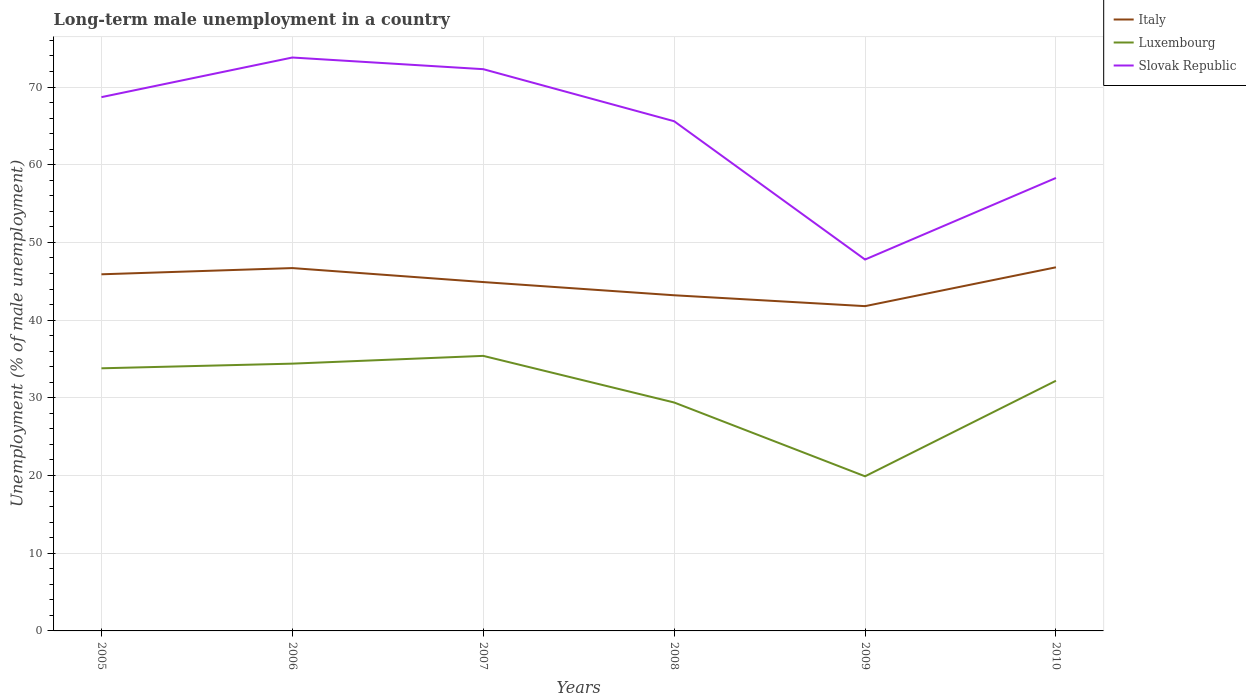Is the number of lines equal to the number of legend labels?
Offer a terse response. Yes. Across all years, what is the maximum percentage of long-term unemployed male population in Slovak Republic?
Give a very brief answer. 47.8. In which year was the percentage of long-term unemployed male population in Luxembourg maximum?
Offer a very short reply. 2009. What is the total percentage of long-term unemployed male population in Luxembourg in the graph?
Give a very brief answer. -1.6. What is the difference between the highest and the second highest percentage of long-term unemployed male population in Luxembourg?
Your response must be concise. 15.5. How many years are there in the graph?
Your answer should be compact. 6. What is the difference between two consecutive major ticks on the Y-axis?
Your response must be concise. 10. Does the graph contain grids?
Provide a succinct answer. Yes. Where does the legend appear in the graph?
Offer a very short reply. Top right. How are the legend labels stacked?
Your response must be concise. Vertical. What is the title of the graph?
Offer a terse response. Long-term male unemployment in a country. Does "Sub-Saharan Africa (all income levels)" appear as one of the legend labels in the graph?
Offer a very short reply. No. What is the label or title of the X-axis?
Give a very brief answer. Years. What is the label or title of the Y-axis?
Make the answer very short. Unemployment (% of male unemployment). What is the Unemployment (% of male unemployment) in Italy in 2005?
Ensure brevity in your answer.  45.9. What is the Unemployment (% of male unemployment) in Luxembourg in 2005?
Your answer should be compact. 33.8. What is the Unemployment (% of male unemployment) in Slovak Republic in 2005?
Offer a very short reply. 68.7. What is the Unemployment (% of male unemployment) of Italy in 2006?
Ensure brevity in your answer.  46.7. What is the Unemployment (% of male unemployment) in Luxembourg in 2006?
Ensure brevity in your answer.  34.4. What is the Unemployment (% of male unemployment) in Slovak Republic in 2006?
Give a very brief answer. 73.8. What is the Unemployment (% of male unemployment) of Italy in 2007?
Ensure brevity in your answer.  44.9. What is the Unemployment (% of male unemployment) of Luxembourg in 2007?
Offer a very short reply. 35.4. What is the Unemployment (% of male unemployment) in Slovak Republic in 2007?
Offer a very short reply. 72.3. What is the Unemployment (% of male unemployment) of Italy in 2008?
Offer a terse response. 43.2. What is the Unemployment (% of male unemployment) of Luxembourg in 2008?
Your response must be concise. 29.4. What is the Unemployment (% of male unemployment) in Slovak Republic in 2008?
Your answer should be very brief. 65.6. What is the Unemployment (% of male unemployment) in Italy in 2009?
Ensure brevity in your answer.  41.8. What is the Unemployment (% of male unemployment) of Luxembourg in 2009?
Offer a very short reply. 19.9. What is the Unemployment (% of male unemployment) of Slovak Republic in 2009?
Offer a very short reply. 47.8. What is the Unemployment (% of male unemployment) of Italy in 2010?
Your response must be concise. 46.8. What is the Unemployment (% of male unemployment) in Luxembourg in 2010?
Ensure brevity in your answer.  32.2. What is the Unemployment (% of male unemployment) in Slovak Republic in 2010?
Your answer should be very brief. 58.3. Across all years, what is the maximum Unemployment (% of male unemployment) of Italy?
Your answer should be compact. 46.8. Across all years, what is the maximum Unemployment (% of male unemployment) in Luxembourg?
Your answer should be compact. 35.4. Across all years, what is the maximum Unemployment (% of male unemployment) in Slovak Republic?
Make the answer very short. 73.8. Across all years, what is the minimum Unemployment (% of male unemployment) of Italy?
Ensure brevity in your answer.  41.8. Across all years, what is the minimum Unemployment (% of male unemployment) of Luxembourg?
Provide a succinct answer. 19.9. Across all years, what is the minimum Unemployment (% of male unemployment) of Slovak Republic?
Your answer should be compact. 47.8. What is the total Unemployment (% of male unemployment) in Italy in the graph?
Ensure brevity in your answer.  269.3. What is the total Unemployment (% of male unemployment) of Luxembourg in the graph?
Give a very brief answer. 185.1. What is the total Unemployment (% of male unemployment) of Slovak Republic in the graph?
Provide a succinct answer. 386.5. What is the difference between the Unemployment (% of male unemployment) in Italy in 2005 and that in 2006?
Offer a very short reply. -0.8. What is the difference between the Unemployment (% of male unemployment) of Slovak Republic in 2005 and that in 2006?
Give a very brief answer. -5.1. What is the difference between the Unemployment (% of male unemployment) of Slovak Republic in 2005 and that in 2007?
Offer a very short reply. -3.6. What is the difference between the Unemployment (% of male unemployment) of Italy in 2005 and that in 2008?
Your response must be concise. 2.7. What is the difference between the Unemployment (% of male unemployment) of Slovak Republic in 2005 and that in 2008?
Your answer should be very brief. 3.1. What is the difference between the Unemployment (% of male unemployment) in Italy in 2005 and that in 2009?
Provide a short and direct response. 4.1. What is the difference between the Unemployment (% of male unemployment) in Slovak Republic in 2005 and that in 2009?
Provide a succinct answer. 20.9. What is the difference between the Unemployment (% of male unemployment) in Italy in 2005 and that in 2010?
Offer a very short reply. -0.9. What is the difference between the Unemployment (% of male unemployment) in Luxembourg in 2005 and that in 2010?
Make the answer very short. 1.6. What is the difference between the Unemployment (% of male unemployment) of Slovak Republic in 2005 and that in 2010?
Ensure brevity in your answer.  10.4. What is the difference between the Unemployment (% of male unemployment) of Slovak Republic in 2006 and that in 2008?
Your answer should be very brief. 8.2. What is the difference between the Unemployment (% of male unemployment) in Italy in 2006 and that in 2009?
Provide a succinct answer. 4.9. What is the difference between the Unemployment (% of male unemployment) of Slovak Republic in 2006 and that in 2009?
Ensure brevity in your answer.  26. What is the difference between the Unemployment (% of male unemployment) in Slovak Republic in 2006 and that in 2010?
Your answer should be compact. 15.5. What is the difference between the Unemployment (% of male unemployment) in Italy in 2007 and that in 2008?
Offer a terse response. 1.7. What is the difference between the Unemployment (% of male unemployment) of Luxembourg in 2007 and that in 2008?
Your answer should be compact. 6. What is the difference between the Unemployment (% of male unemployment) of Slovak Republic in 2007 and that in 2008?
Give a very brief answer. 6.7. What is the difference between the Unemployment (% of male unemployment) of Italy in 2008 and that in 2009?
Make the answer very short. 1.4. What is the difference between the Unemployment (% of male unemployment) of Luxembourg in 2008 and that in 2009?
Your answer should be very brief. 9.5. What is the difference between the Unemployment (% of male unemployment) of Slovak Republic in 2008 and that in 2009?
Offer a very short reply. 17.8. What is the difference between the Unemployment (% of male unemployment) of Slovak Republic in 2008 and that in 2010?
Keep it short and to the point. 7.3. What is the difference between the Unemployment (% of male unemployment) of Luxembourg in 2009 and that in 2010?
Ensure brevity in your answer.  -12.3. What is the difference between the Unemployment (% of male unemployment) in Slovak Republic in 2009 and that in 2010?
Offer a very short reply. -10.5. What is the difference between the Unemployment (% of male unemployment) of Italy in 2005 and the Unemployment (% of male unemployment) of Luxembourg in 2006?
Offer a very short reply. 11.5. What is the difference between the Unemployment (% of male unemployment) in Italy in 2005 and the Unemployment (% of male unemployment) in Slovak Republic in 2006?
Offer a very short reply. -27.9. What is the difference between the Unemployment (% of male unemployment) in Luxembourg in 2005 and the Unemployment (% of male unemployment) in Slovak Republic in 2006?
Offer a very short reply. -40. What is the difference between the Unemployment (% of male unemployment) of Italy in 2005 and the Unemployment (% of male unemployment) of Luxembourg in 2007?
Offer a terse response. 10.5. What is the difference between the Unemployment (% of male unemployment) in Italy in 2005 and the Unemployment (% of male unemployment) in Slovak Republic in 2007?
Your answer should be very brief. -26.4. What is the difference between the Unemployment (% of male unemployment) of Luxembourg in 2005 and the Unemployment (% of male unemployment) of Slovak Republic in 2007?
Keep it short and to the point. -38.5. What is the difference between the Unemployment (% of male unemployment) in Italy in 2005 and the Unemployment (% of male unemployment) in Luxembourg in 2008?
Make the answer very short. 16.5. What is the difference between the Unemployment (% of male unemployment) in Italy in 2005 and the Unemployment (% of male unemployment) in Slovak Republic in 2008?
Offer a terse response. -19.7. What is the difference between the Unemployment (% of male unemployment) in Luxembourg in 2005 and the Unemployment (% of male unemployment) in Slovak Republic in 2008?
Your answer should be compact. -31.8. What is the difference between the Unemployment (% of male unemployment) in Italy in 2005 and the Unemployment (% of male unemployment) in Slovak Republic in 2009?
Provide a succinct answer. -1.9. What is the difference between the Unemployment (% of male unemployment) in Luxembourg in 2005 and the Unemployment (% of male unemployment) in Slovak Republic in 2009?
Make the answer very short. -14. What is the difference between the Unemployment (% of male unemployment) in Italy in 2005 and the Unemployment (% of male unemployment) in Slovak Republic in 2010?
Offer a very short reply. -12.4. What is the difference between the Unemployment (% of male unemployment) in Luxembourg in 2005 and the Unemployment (% of male unemployment) in Slovak Republic in 2010?
Offer a terse response. -24.5. What is the difference between the Unemployment (% of male unemployment) of Italy in 2006 and the Unemployment (% of male unemployment) of Slovak Republic in 2007?
Your answer should be very brief. -25.6. What is the difference between the Unemployment (% of male unemployment) in Luxembourg in 2006 and the Unemployment (% of male unemployment) in Slovak Republic in 2007?
Make the answer very short. -37.9. What is the difference between the Unemployment (% of male unemployment) of Italy in 2006 and the Unemployment (% of male unemployment) of Luxembourg in 2008?
Your answer should be compact. 17.3. What is the difference between the Unemployment (% of male unemployment) of Italy in 2006 and the Unemployment (% of male unemployment) of Slovak Republic in 2008?
Provide a succinct answer. -18.9. What is the difference between the Unemployment (% of male unemployment) in Luxembourg in 2006 and the Unemployment (% of male unemployment) in Slovak Republic in 2008?
Provide a succinct answer. -31.2. What is the difference between the Unemployment (% of male unemployment) of Italy in 2006 and the Unemployment (% of male unemployment) of Luxembourg in 2009?
Give a very brief answer. 26.8. What is the difference between the Unemployment (% of male unemployment) in Luxembourg in 2006 and the Unemployment (% of male unemployment) in Slovak Republic in 2009?
Give a very brief answer. -13.4. What is the difference between the Unemployment (% of male unemployment) in Italy in 2006 and the Unemployment (% of male unemployment) in Luxembourg in 2010?
Your answer should be very brief. 14.5. What is the difference between the Unemployment (% of male unemployment) in Luxembourg in 2006 and the Unemployment (% of male unemployment) in Slovak Republic in 2010?
Your response must be concise. -23.9. What is the difference between the Unemployment (% of male unemployment) in Italy in 2007 and the Unemployment (% of male unemployment) in Luxembourg in 2008?
Make the answer very short. 15.5. What is the difference between the Unemployment (% of male unemployment) of Italy in 2007 and the Unemployment (% of male unemployment) of Slovak Republic in 2008?
Give a very brief answer. -20.7. What is the difference between the Unemployment (% of male unemployment) in Luxembourg in 2007 and the Unemployment (% of male unemployment) in Slovak Republic in 2008?
Offer a very short reply. -30.2. What is the difference between the Unemployment (% of male unemployment) of Luxembourg in 2007 and the Unemployment (% of male unemployment) of Slovak Republic in 2010?
Offer a terse response. -22.9. What is the difference between the Unemployment (% of male unemployment) of Italy in 2008 and the Unemployment (% of male unemployment) of Luxembourg in 2009?
Your response must be concise. 23.3. What is the difference between the Unemployment (% of male unemployment) in Italy in 2008 and the Unemployment (% of male unemployment) in Slovak Republic in 2009?
Offer a very short reply. -4.6. What is the difference between the Unemployment (% of male unemployment) in Luxembourg in 2008 and the Unemployment (% of male unemployment) in Slovak Republic in 2009?
Provide a short and direct response. -18.4. What is the difference between the Unemployment (% of male unemployment) of Italy in 2008 and the Unemployment (% of male unemployment) of Luxembourg in 2010?
Offer a very short reply. 11. What is the difference between the Unemployment (% of male unemployment) in Italy in 2008 and the Unemployment (% of male unemployment) in Slovak Republic in 2010?
Make the answer very short. -15.1. What is the difference between the Unemployment (% of male unemployment) in Luxembourg in 2008 and the Unemployment (% of male unemployment) in Slovak Republic in 2010?
Ensure brevity in your answer.  -28.9. What is the difference between the Unemployment (% of male unemployment) in Italy in 2009 and the Unemployment (% of male unemployment) in Slovak Republic in 2010?
Keep it short and to the point. -16.5. What is the difference between the Unemployment (% of male unemployment) in Luxembourg in 2009 and the Unemployment (% of male unemployment) in Slovak Republic in 2010?
Provide a succinct answer. -38.4. What is the average Unemployment (% of male unemployment) in Italy per year?
Provide a short and direct response. 44.88. What is the average Unemployment (% of male unemployment) in Luxembourg per year?
Ensure brevity in your answer.  30.85. What is the average Unemployment (% of male unemployment) of Slovak Republic per year?
Give a very brief answer. 64.42. In the year 2005, what is the difference between the Unemployment (% of male unemployment) in Italy and Unemployment (% of male unemployment) in Slovak Republic?
Give a very brief answer. -22.8. In the year 2005, what is the difference between the Unemployment (% of male unemployment) in Luxembourg and Unemployment (% of male unemployment) in Slovak Republic?
Ensure brevity in your answer.  -34.9. In the year 2006, what is the difference between the Unemployment (% of male unemployment) of Italy and Unemployment (% of male unemployment) of Slovak Republic?
Offer a terse response. -27.1. In the year 2006, what is the difference between the Unemployment (% of male unemployment) of Luxembourg and Unemployment (% of male unemployment) of Slovak Republic?
Ensure brevity in your answer.  -39.4. In the year 2007, what is the difference between the Unemployment (% of male unemployment) in Italy and Unemployment (% of male unemployment) in Luxembourg?
Ensure brevity in your answer.  9.5. In the year 2007, what is the difference between the Unemployment (% of male unemployment) in Italy and Unemployment (% of male unemployment) in Slovak Republic?
Your answer should be compact. -27.4. In the year 2007, what is the difference between the Unemployment (% of male unemployment) of Luxembourg and Unemployment (% of male unemployment) of Slovak Republic?
Your answer should be compact. -36.9. In the year 2008, what is the difference between the Unemployment (% of male unemployment) of Italy and Unemployment (% of male unemployment) of Luxembourg?
Provide a succinct answer. 13.8. In the year 2008, what is the difference between the Unemployment (% of male unemployment) of Italy and Unemployment (% of male unemployment) of Slovak Republic?
Provide a short and direct response. -22.4. In the year 2008, what is the difference between the Unemployment (% of male unemployment) of Luxembourg and Unemployment (% of male unemployment) of Slovak Republic?
Provide a short and direct response. -36.2. In the year 2009, what is the difference between the Unemployment (% of male unemployment) of Italy and Unemployment (% of male unemployment) of Luxembourg?
Provide a short and direct response. 21.9. In the year 2009, what is the difference between the Unemployment (% of male unemployment) in Italy and Unemployment (% of male unemployment) in Slovak Republic?
Keep it short and to the point. -6. In the year 2009, what is the difference between the Unemployment (% of male unemployment) of Luxembourg and Unemployment (% of male unemployment) of Slovak Republic?
Keep it short and to the point. -27.9. In the year 2010, what is the difference between the Unemployment (% of male unemployment) of Italy and Unemployment (% of male unemployment) of Luxembourg?
Your answer should be compact. 14.6. In the year 2010, what is the difference between the Unemployment (% of male unemployment) of Luxembourg and Unemployment (% of male unemployment) of Slovak Republic?
Ensure brevity in your answer.  -26.1. What is the ratio of the Unemployment (% of male unemployment) of Italy in 2005 to that in 2006?
Provide a short and direct response. 0.98. What is the ratio of the Unemployment (% of male unemployment) of Luxembourg in 2005 to that in 2006?
Offer a terse response. 0.98. What is the ratio of the Unemployment (% of male unemployment) of Slovak Republic in 2005 to that in 2006?
Offer a very short reply. 0.93. What is the ratio of the Unemployment (% of male unemployment) of Italy in 2005 to that in 2007?
Provide a succinct answer. 1.02. What is the ratio of the Unemployment (% of male unemployment) of Luxembourg in 2005 to that in 2007?
Offer a very short reply. 0.95. What is the ratio of the Unemployment (% of male unemployment) in Slovak Republic in 2005 to that in 2007?
Make the answer very short. 0.95. What is the ratio of the Unemployment (% of male unemployment) in Italy in 2005 to that in 2008?
Make the answer very short. 1.06. What is the ratio of the Unemployment (% of male unemployment) in Luxembourg in 2005 to that in 2008?
Keep it short and to the point. 1.15. What is the ratio of the Unemployment (% of male unemployment) in Slovak Republic in 2005 to that in 2008?
Your answer should be compact. 1.05. What is the ratio of the Unemployment (% of male unemployment) in Italy in 2005 to that in 2009?
Your response must be concise. 1.1. What is the ratio of the Unemployment (% of male unemployment) of Luxembourg in 2005 to that in 2009?
Provide a succinct answer. 1.7. What is the ratio of the Unemployment (% of male unemployment) of Slovak Republic in 2005 to that in 2009?
Your answer should be compact. 1.44. What is the ratio of the Unemployment (% of male unemployment) in Italy in 2005 to that in 2010?
Provide a succinct answer. 0.98. What is the ratio of the Unemployment (% of male unemployment) of Luxembourg in 2005 to that in 2010?
Offer a very short reply. 1.05. What is the ratio of the Unemployment (% of male unemployment) of Slovak Republic in 2005 to that in 2010?
Provide a succinct answer. 1.18. What is the ratio of the Unemployment (% of male unemployment) of Italy in 2006 to that in 2007?
Ensure brevity in your answer.  1.04. What is the ratio of the Unemployment (% of male unemployment) in Luxembourg in 2006 to that in 2007?
Ensure brevity in your answer.  0.97. What is the ratio of the Unemployment (% of male unemployment) in Slovak Republic in 2006 to that in 2007?
Provide a short and direct response. 1.02. What is the ratio of the Unemployment (% of male unemployment) of Italy in 2006 to that in 2008?
Make the answer very short. 1.08. What is the ratio of the Unemployment (% of male unemployment) in Luxembourg in 2006 to that in 2008?
Provide a succinct answer. 1.17. What is the ratio of the Unemployment (% of male unemployment) in Slovak Republic in 2006 to that in 2008?
Offer a terse response. 1.12. What is the ratio of the Unemployment (% of male unemployment) in Italy in 2006 to that in 2009?
Your answer should be compact. 1.12. What is the ratio of the Unemployment (% of male unemployment) of Luxembourg in 2006 to that in 2009?
Your answer should be compact. 1.73. What is the ratio of the Unemployment (% of male unemployment) of Slovak Republic in 2006 to that in 2009?
Provide a short and direct response. 1.54. What is the ratio of the Unemployment (% of male unemployment) in Italy in 2006 to that in 2010?
Your answer should be compact. 1. What is the ratio of the Unemployment (% of male unemployment) of Luxembourg in 2006 to that in 2010?
Your answer should be very brief. 1.07. What is the ratio of the Unemployment (% of male unemployment) in Slovak Republic in 2006 to that in 2010?
Your answer should be very brief. 1.27. What is the ratio of the Unemployment (% of male unemployment) of Italy in 2007 to that in 2008?
Your answer should be very brief. 1.04. What is the ratio of the Unemployment (% of male unemployment) in Luxembourg in 2007 to that in 2008?
Keep it short and to the point. 1.2. What is the ratio of the Unemployment (% of male unemployment) in Slovak Republic in 2007 to that in 2008?
Provide a short and direct response. 1.1. What is the ratio of the Unemployment (% of male unemployment) in Italy in 2007 to that in 2009?
Ensure brevity in your answer.  1.07. What is the ratio of the Unemployment (% of male unemployment) in Luxembourg in 2007 to that in 2009?
Your answer should be compact. 1.78. What is the ratio of the Unemployment (% of male unemployment) of Slovak Republic in 2007 to that in 2009?
Keep it short and to the point. 1.51. What is the ratio of the Unemployment (% of male unemployment) of Italy in 2007 to that in 2010?
Provide a succinct answer. 0.96. What is the ratio of the Unemployment (% of male unemployment) in Luxembourg in 2007 to that in 2010?
Provide a succinct answer. 1.1. What is the ratio of the Unemployment (% of male unemployment) of Slovak Republic in 2007 to that in 2010?
Your answer should be compact. 1.24. What is the ratio of the Unemployment (% of male unemployment) of Italy in 2008 to that in 2009?
Make the answer very short. 1.03. What is the ratio of the Unemployment (% of male unemployment) in Luxembourg in 2008 to that in 2009?
Give a very brief answer. 1.48. What is the ratio of the Unemployment (% of male unemployment) of Slovak Republic in 2008 to that in 2009?
Your answer should be compact. 1.37. What is the ratio of the Unemployment (% of male unemployment) in Luxembourg in 2008 to that in 2010?
Give a very brief answer. 0.91. What is the ratio of the Unemployment (% of male unemployment) in Slovak Republic in 2008 to that in 2010?
Provide a short and direct response. 1.13. What is the ratio of the Unemployment (% of male unemployment) of Italy in 2009 to that in 2010?
Your answer should be very brief. 0.89. What is the ratio of the Unemployment (% of male unemployment) in Luxembourg in 2009 to that in 2010?
Make the answer very short. 0.62. What is the ratio of the Unemployment (% of male unemployment) in Slovak Republic in 2009 to that in 2010?
Ensure brevity in your answer.  0.82. What is the difference between the highest and the second highest Unemployment (% of male unemployment) in Luxembourg?
Your response must be concise. 1. What is the difference between the highest and the second highest Unemployment (% of male unemployment) in Slovak Republic?
Provide a short and direct response. 1.5. What is the difference between the highest and the lowest Unemployment (% of male unemployment) of Italy?
Provide a succinct answer. 5. What is the difference between the highest and the lowest Unemployment (% of male unemployment) in Luxembourg?
Offer a very short reply. 15.5. What is the difference between the highest and the lowest Unemployment (% of male unemployment) of Slovak Republic?
Ensure brevity in your answer.  26. 